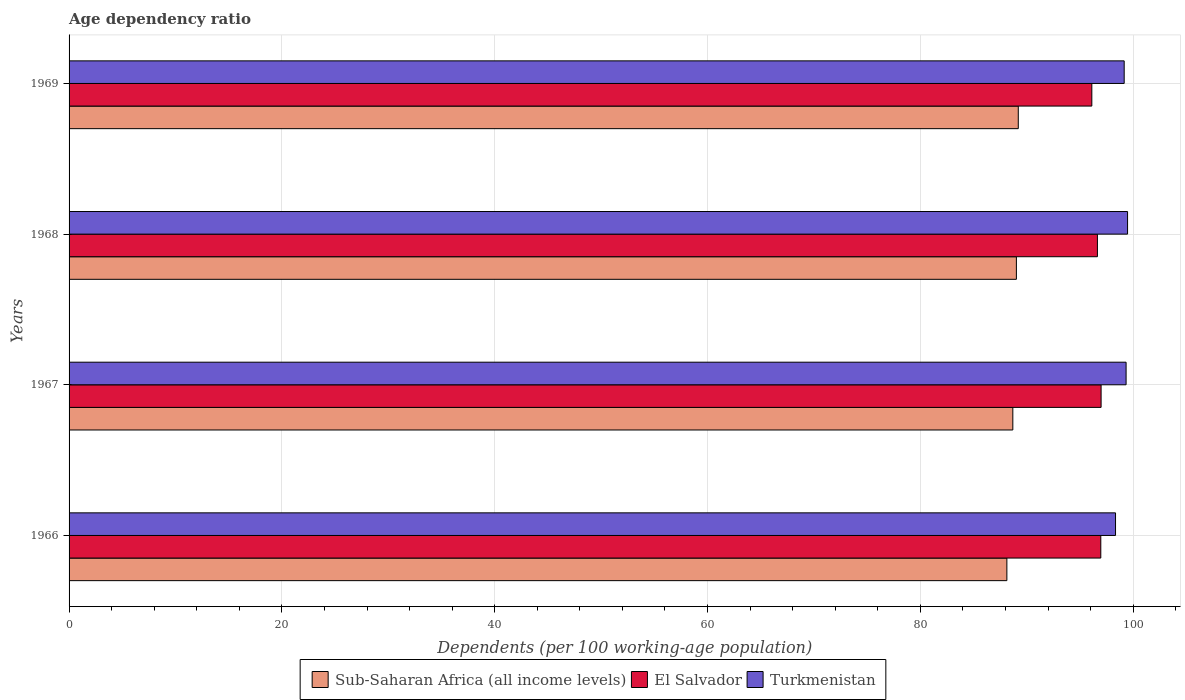How many different coloured bars are there?
Your answer should be very brief. 3. How many groups of bars are there?
Keep it short and to the point. 4. What is the label of the 4th group of bars from the top?
Give a very brief answer. 1966. What is the age dependency ratio in in Sub-Saharan Africa (all income levels) in 1967?
Make the answer very short. 88.69. Across all years, what is the maximum age dependency ratio in in El Salvador?
Provide a succinct answer. 96.99. Across all years, what is the minimum age dependency ratio in in Turkmenistan?
Your response must be concise. 98.34. In which year was the age dependency ratio in in Sub-Saharan Africa (all income levels) maximum?
Make the answer very short. 1969. In which year was the age dependency ratio in in Sub-Saharan Africa (all income levels) minimum?
Give a very brief answer. 1966. What is the total age dependency ratio in in Sub-Saharan Africa (all income levels) in the graph?
Your answer should be compact. 355.05. What is the difference between the age dependency ratio in in El Salvador in 1966 and that in 1967?
Provide a succinct answer. -0.03. What is the difference between the age dependency ratio in in El Salvador in 1966 and the age dependency ratio in in Sub-Saharan Africa (all income levels) in 1969?
Offer a very short reply. 7.76. What is the average age dependency ratio in in El Salvador per year?
Provide a succinct answer. 96.67. In the year 1968, what is the difference between the age dependency ratio in in Sub-Saharan Africa (all income levels) and age dependency ratio in in Turkmenistan?
Provide a short and direct response. -10.45. What is the ratio of the age dependency ratio in in Turkmenistan in 1966 to that in 1969?
Make the answer very short. 0.99. Is the difference between the age dependency ratio in in Sub-Saharan Africa (all income levels) in 1968 and 1969 greater than the difference between the age dependency ratio in in Turkmenistan in 1968 and 1969?
Your answer should be compact. No. What is the difference between the highest and the second highest age dependency ratio in in El Salvador?
Ensure brevity in your answer.  0.03. What is the difference between the highest and the lowest age dependency ratio in in Sub-Saharan Africa (all income levels)?
Your answer should be compact. 1.07. In how many years, is the age dependency ratio in in Sub-Saharan Africa (all income levels) greater than the average age dependency ratio in in Sub-Saharan Africa (all income levels) taken over all years?
Provide a short and direct response. 2. Is the sum of the age dependency ratio in in Turkmenistan in 1967 and 1969 greater than the maximum age dependency ratio in in Sub-Saharan Africa (all income levels) across all years?
Offer a terse response. Yes. What does the 2nd bar from the top in 1969 represents?
Give a very brief answer. El Salvador. What does the 1st bar from the bottom in 1966 represents?
Offer a very short reply. Sub-Saharan Africa (all income levels). Are all the bars in the graph horizontal?
Ensure brevity in your answer.  Yes. How many years are there in the graph?
Your answer should be very brief. 4. Are the values on the major ticks of X-axis written in scientific E-notation?
Provide a short and direct response. No. Does the graph contain any zero values?
Offer a very short reply. No. Does the graph contain grids?
Provide a short and direct response. Yes. Where does the legend appear in the graph?
Offer a very short reply. Bottom center. What is the title of the graph?
Ensure brevity in your answer.  Age dependency ratio. Does "Euro area" appear as one of the legend labels in the graph?
Provide a succinct answer. No. What is the label or title of the X-axis?
Your answer should be compact. Dependents (per 100 working-age population). What is the label or title of the Y-axis?
Give a very brief answer. Years. What is the Dependents (per 100 working-age population) in Sub-Saharan Africa (all income levels) in 1966?
Your answer should be compact. 88.13. What is the Dependents (per 100 working-age population) in El Salvador in 1966?
Offer a very short reply. 96.96. What is the Dependents (per 100 working-age population) of Turkmenistan in 1966?
Keep it short and to the point. 98.34. What is the Dependents (per 100 working-age population) in Sub-Saharan Africa (all income levels) in 1967?
Your response must be concise. 88.69. What is the Dependents (per 100 working-age population) of El Salvador in 1967?
Keep it short and to the point. 96.99. What is the Dependents (per 100 working-age population) of Turkmenistan in 1967?
Your response must be concise. 99.33. What is the Dependents (per 100 working-age population) in Sub-Saharan Africa (all income levels) in 1968?
Your response must be concise. 89.03. What is the Dependents (per 100 working-age population) of El Salvador in 1968?
Your response must be concise. 96.64. What is the Dependents (per 100 working-age population) of Turkmenistan in 1968?
Your answer should be very brief. 99.47. What is the Dependents (per 100 working-age population) of Sub-Saharan Africa (all income levels) in 1969?
Offer a terse response. 89.2. What is the Dependents (per 100 working-age population) of El Salvador in 1969?
Offer a terse response. 96.11. What is the Dependents (per 100 working-age population) in Turkmenistan in 1969?
Offer a very short reply. 99.16. Across all years, what is the maximum Dependents (per 100 working-age population) in Sub-Saharan Africa (all income levels)?
Keep it short and to the point. 89.2. Across all years, what is the maximum Dependents (per 100 working-age population) in El Salvador?
Offer a terse response. 96.99. Across all years, what is the maximum Dependents (per 100 working-age population) in Turkmenistan?
Keep it short and to the point. 99.47. Across all years, what is the minimum Dependents (per 100 working-age population) of Sub-Saharan Africa (all income levels)?
Your response must be concise. 88.13. Across all years, what is the minimum Dependents (per 100 working-age population) in El Salvador?
Keep it short and to the point. 96.11. Across all years, what is the minimum Dependents (per 100 working-age population) in Turkmenistan?
Ensure brevity in your answer.  98.34. What is the total Dependents (per 100 working-age population) in Sub-Saharan Africa (all income levels) in the graph?
Ensure brevity in your answer.  355.05. What is the total Dependents (per 100 working-age population) of El Salvador in the graph?
Your answer should be very brief. 386.7. What is the total Dependents (per 100 working-age population) of Turkmenistan in the graph?
Your answer should be very brief. 396.31. What is the difference between the Dependents (per 100 working-age population) in Sub-Saharan Africa (all income levels) in 1966 and that in 1967?
Your answer should be very brief. -0.56. What is the difference between the Dependents (per 100 working-age population) of El Salvador in 1966 and that in 1967?
Provide a succinct answer. -0.03. What is the difference between the Dependents (per 100 working-age population) of Turkmenistan in 1966 and that in 1967?
Your response must be concise. -0.99. What is the difference between the Dependents (per 100 working-age population) in Sub-Saharan Africa (all income levels) in 1966 and that in 1968?
Your answer should be compact. -0.89. What is the difference between the Dependents (per 100 working-age population) of El Salvador in 1966 and that in 1968?
Your response must be concise. 0.32. What is the difference between the Dependents (per 100 working-age population) of Turkmenistan in 1966 and that in 1968?
Ensure brevity in your answer.  -1.13. What is the difference between the Dependents (per 100 working-age population) of Sub-Saharan Africa (all income levels) in 1966 and that in 1969?
Your answer should be very brief. -1.07. What is the difference between the Dependents (per 100 working-age population) of El Salvador in 1966 and that in 1969?
Offer a very short reply. 0.84. What is the difference between the Dependents (per 100 working-age population) in Turkmenistan in 1966 and that in 1969?
Provide a succinct answer. -0.81. What is the difference between the Dependents (per 100 working-age population) in Sub-Saharan Africa (all income levels) in 1967 and that in 1968?
Make the answer very short. -0.33. What is the difference between the Dependents (per 100 working-age population) of El Salvador in 1967 and that in 1968?
Offer a terse response. 0.35. What is the difference between the Dependents (per 100 working-age population) in Turkmenistan in 1967 and that in 1968?
Provide a short and direct response. -0.14. What is the difference between the Dependents (per 100 working-age population) in Sub-Saharan Africa (all income levels) in 1967 and that in 1969?
Give a very brief answer. -0.51. What is the difference between the Dependents (per 100 working-age population) in El Salvador in 1967 and that in 1969?
Offer a terse response. 0.87. What is the difference between the Dependents (per 100 working-age population) in Turkmenistan in 1967 and that in 1969?
Your response must be concise. 0.18. What is the difference between the Dependents (per 100 working-age population) of Sub-Saharan Africa (all income levels) in 1968 and that in 1969?
Ensure brevity in your answer.  -0.18. What is the difference between the Dependents (per 100 working-age population) in El Salvador in 1968 and that in 1969?
Keep it short and to the point. 0.53. What is the difference between the Dependents (per 100 working-age population) in Turkmenistan in 1968 and that in 1969?
Provide a succinct answer. 0.32. What is the difference between the Dependents (per 100 working-age population) in Sub-Saharan Africa (all income levels) in 1966 and the Dependents (per 100 working-age population) in El Salvador in 1967?
Give a very brief answer. -8.86. What is the difference between the Dependents (per 100 working-age population) of Sub-Saharan Africa (all income levels) in 1966 and the Dependents (per 100 working-age population) of Turkmenistan in 1967?
Your answer should be very brief. -11.2. What is the difference between the Dependents (per 100 working-age population) of El Salvador in 1966 and the Dependents (per 100 working-age population) of Turkmenistan in 1967?
Your answer should be compact. -2.38. What is the difference between the Dependents (per 100 working-age population) in Sub-Saharan Africa (all income levels) in 1966 and the Dependents (per 100 working-age population) in El Salvador in 1968?
Your answer should be compact. -8.51. What is the difference between the Dependents (per 100 working-age population) of Sub-Saharan Africa (all income levels) in 1966 and the Dependents (per 100 working-age population) of Turkmenistan in 1968?
Provide a short and direct response. -11.34. What is the difference between the Dependents (per 100 working-age population) of El Salvador in 1966 and the Dependents (per 100 working-age population) of Turkmenistan in 1968?
Your answer should be compact. -2.52. What is the difference between the Dependents (per 100 working-age population) in Sub-Saharan Africa (all income levels) in 1966 and the Dependents (per 100 working-age population) in El Salvador in 1969?
Ensure brevity in your answer.  -7.98. What is the difference between the Dependents (per 100 working-age population) in Sub-Saharan Africa (all income levels) in 1966 and the Dependents (per 100 working-age population) in Turkmenistan in 1969?
Offer a terse response. -11.02. What is the difference between the Dependents (per 100 working-age population) in El Salvador in 1966 and the Dependents (per 100 working-age population) in Turkmenistan in 1969?
Your answer should be compact. -2.2. What is the difference between the Dependents (per 100 working-age population) in Sub-Saharan Africa (all income levels) in 1967 and the Dependents (per 100 working-age population) in El Salvador in 1968?
Provide a succinct answer. -7.95. What is the difference between the Dependents (per 100 working-age population) of Sub-Saharan Africa (all income levels) in 1967 and the Dependents (per 100 working-age population) of Turkmenistan in 1968?
Provide a short and direct response. -10.78. What is the difference between the Dependents (per 100 working-age population) in El Salvador in 1967 and the Dependents (per 100 working-age population) in Turkmenistan in 1968?
Offer a very short reply. -2.49. What is the difference between the Dependents (per 100 working-age population) of Sub-Saharan Africa (all income levels) in 1967 and the Dependents (per 100 working-age population) of El Salvador in 1969?
Provide a succinct answer. -7.42. What is the difference between the Dependents (per 100 working-age population) of Sub-Saharan Africa (all income levels) in 1967 and the Dependents (per 100 working-age population) of Turkmenistan in 1969?
Your response must be concise. -10.46. What is the difference between the Dependents (per 100 working-age population) of El Salvador in 1967 and the Dependents (per 100 working-age population) of Turkmenistan in 1969?
Keep it short and to the point. -2.17. What is the difference between the Dependents (per 100 working-age population) of Sub-Saharan Africa (all income levels) in 1968 and the Dependents (per 100 working-age population) of El Salvador in 1969?
Your response must be concise. -7.09. What is the difference between the Dependents (per 100 working-age population) in Sub-Saharan Africa (all income levels) in 1968 and the Dependents (per 100 working-age population) in Turkmenistan in 1969?
Ensure brevity in your answer.  -10.13. What is the difference between the Dependents (per 100 working-age population) in El Salvador in 1968 and the Dependents (per 100 working-age population) in Turkmenistan in 1969?
Provide a succinct answer. -2.51. What is the average Dependents (per 100 working-age population) in Sub-Saharan Africa (all income levels) per year?
Provide a short and direct response. 88.76. What is the average Dependents (per 100 working-age population) of El Salvador per year?
Your answer should be very brief. 96.67. What is the average Dependents (per 100 working-age population) of Turkmenistan per year?
Your answer should be compact. 99.08. In the year 1966, what is the difference between the Dependents (per 100 working-age population) in Sub-Saharan Africa (all income levels) and Dependents (per 100 working-age population) in El Salvador?
Give a very brief answer. -8.83. In the year 1966, what is the difference between the Dependents (per 100 working-age population) in Sub-Saharan Africa (all income levels) and Dependents (per 100 working-age population) in Turkmenistan?
Keep it short and to the point. -10.21. In the year 1966, what is the difference between the Dependents (per 100 working-age population) of El Salvador and Dependents (per 100 working-age population) of Turkmenistan?
Provide a succinct answer. -1.38. In the year 1967, what is the difference between the Dependents (per 100 working-age population) of Sub-Saharan Africa (all income levels) and Dependents (per 100 working-age population) of El Salvador?
Your answer should be compact. -8.29. In the year 1967, what is the difference between the Dependents (per 100 working-age population) in Sub-Saharan Africa (all income levels) and Dependents (per 100 working-age population) in Turkmenistan?
Your response must be concise. -10.64. In the year 1967, what is the difference between the Dependents (per 100 working-age population) of El Salvador and Dependents (per 100 working-age population) of Turkmenistan?
Provide a succinct answer. -2.35. In the year 1968, what is the difference between the Dependents (per 100 working-age population) of Sub-Saharan Africa (all income levels) and Dependents (per 100 working-age population) of El Salvador?
Your answer should be compact. -7.62. In the year 1968, what is the difference between the Dependents (per 100 working-age population) in Sub-Saharan Africa (all income levels) and Dependents (per 100 working-age population) in Turkmenistan?
Offer a very short reply. -10.45. In the year 1968, what is the difference between the Dependents (per 100 working-age population) of El Salvador and Dependents (per 100 working-age population) of Turkmenistan?
Offer a terse response. -2.83. In the year 1969, what is the difference between the Dependents (per 100 working-age population) in Sub-Saharan Africa (all income levels) and Dependents (per 100 working-age population) in El Salvador?
Offer a very short reply. -6.91. In the year 1969, what is the difference between the Dependents (per 100 working-age population) in Sub-Saharan Africa (all income levels) and Dependents (per 100 working-age population) in Turkmenistan?
Provide a succinct answer. -9.95. In the year 1969, what is the difference between the Dependents (per 100 working-age population) in El Salvador and Dependents (per 100 working-age population) in Turkmenistan?
Offer a very short reply. -3.04. What is the ratio of the Dependents (per 100 working-age population) of Sub-Saharan Africa (all income levels) in 1966 to that in 1968?
Your response must be concise. 0.99. What is the ratio of the Dependents (per 100 working-age population) in Sub-Saharan Africa (all income levels) in 1966 to that in 1969?
Offer a terse response. 0.99. What is the ratio of the Dependents (per 100 working-age population) in El Salvador in 1966 to that in 1969?
Your answer should be very brief. 1.01. What is the ratio of the Dependents (per 100 working-age population) in Turkmenistan in 1966 to that in 1969?
Keep it short and to the point. 0.99. What is the ratio of the Dependents (per 100 working-age population) in El Salvador in 1967 to that in 1968?
Provide a short and direct response. 1. What is the ratio of the Dependents (per 100 working-age population) of El Salvador in 1967 to that in 1969?
Make the answer very short. 1.01. What is the ratio of the Dependents (per 100 working-age population) in Turkmenistan in 1967 to that in 1969?
Provide a short and direct response. 1. What is the ratio of the Dependents (per 100 working-age population) in Sub-Saharan Africa (all income levels) in 1968 to that in 1969?
Provide a short and direct response. 1. What is the difference between the highest and the second highest Dependents (per 100 working-age population) of Sub-Saharan Africa (all income levels)?
Offer a terse response. 0.18. What is the difference between the highest and the second highest Dependents (per 100 working-age population) of El Salvador?
Give a very brief answer. 0.03. What is the difference between the highest and the second highest Dependents (per 100 working-age population) in Turkmenistan?
Your response must be concise. 0.14. What is the difference between the highest and the lowest Dependents (per 100 working-age population) in Sub-Saharan Africa (all income levels)?
Provide a short and direct response. 1.07. What is the difference between the highest and the lowest Dependents (per 100 working-age population) of El Salvador?
Provide a succinct answer. 0.87. What is the difference between the highest and the lowest Dependents (per 100 working-age population) in Turkmenistan?
Offer a very short reply. 1.13. 